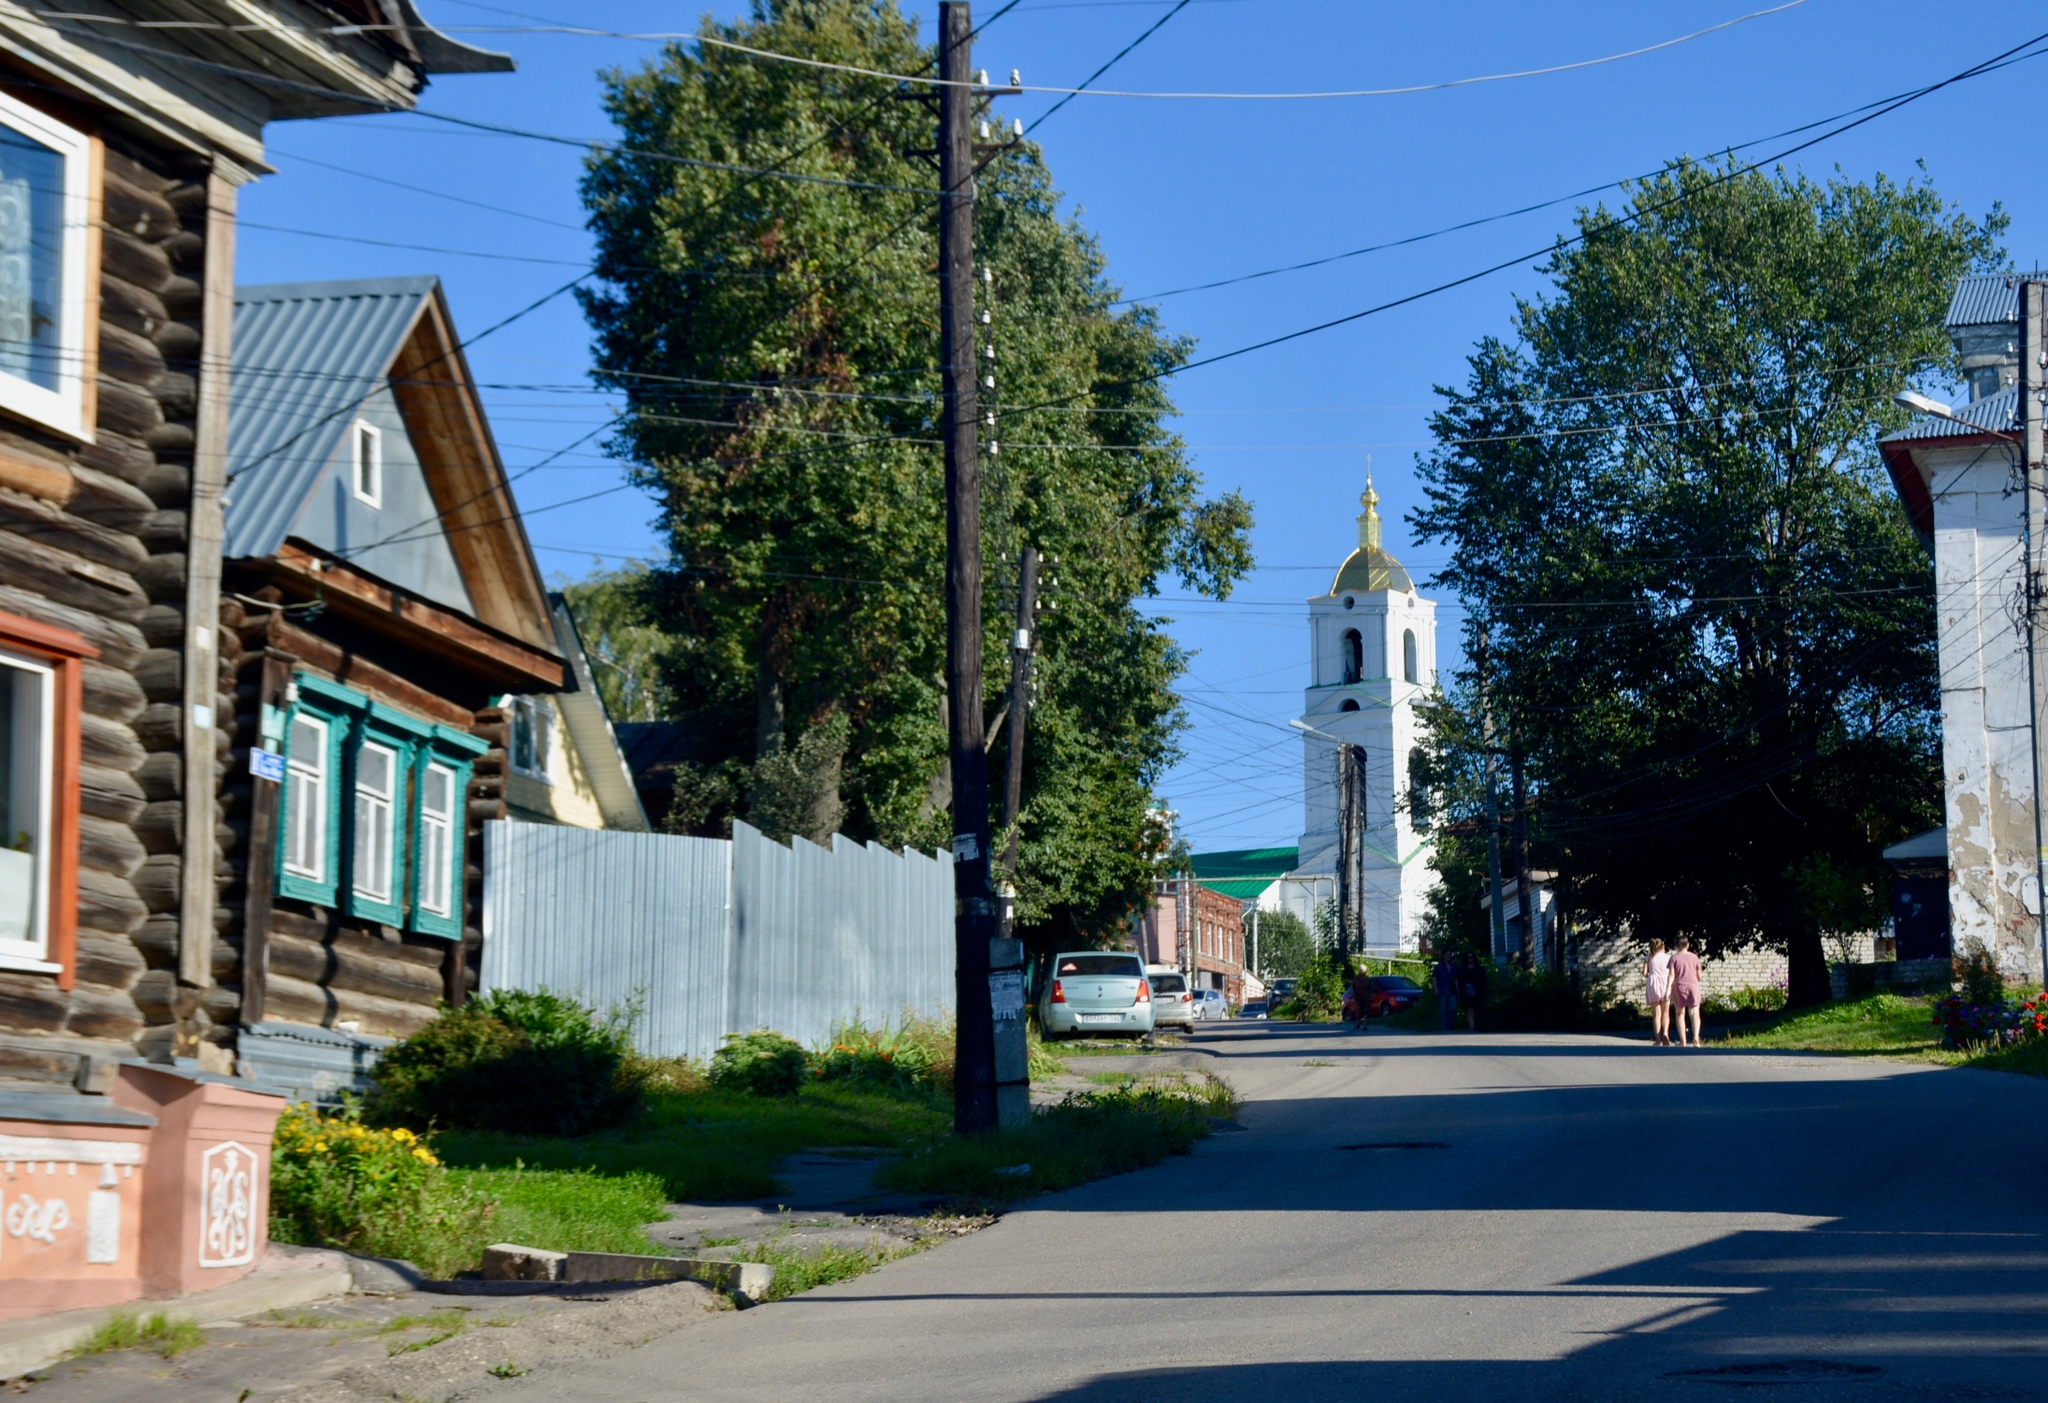How does the environment contribute to the ambiance of this town? The environment plays a crucial role in defining the tranquil ambiance of the town. The abundance of greenery, seen in the mature trees lining the streets and the small patches of grass and shrubs, infuses the area with a fresh, lively vibe. The natural elements harmonize with the wooden architecture, softening the urban features and creating a welcoming, peaceful setting that encourages leisurely walks and appreciation of the simple beauties of town life. 